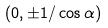<formula> <loc_0><loc_0><loc_500><loc_500>( 0 , \pm 1 / \cos \alpha )</formula> 